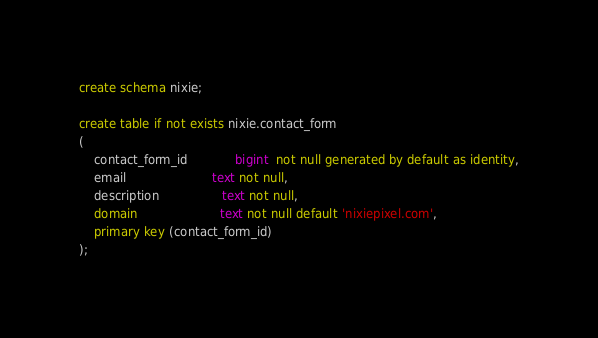<code> <loc_0><loc_0><loc_500><loc_500><_SQL_>create schema nixie;

create table if not exists nixie.contact_form
(
    contact_form_id             bigint  not null generated by default as identity,
    email                       text not null,
    description                 text not null,
    domain                      text not null default 'nixiepixel.com',
    primary key (contact_form_id)
);
</code> 